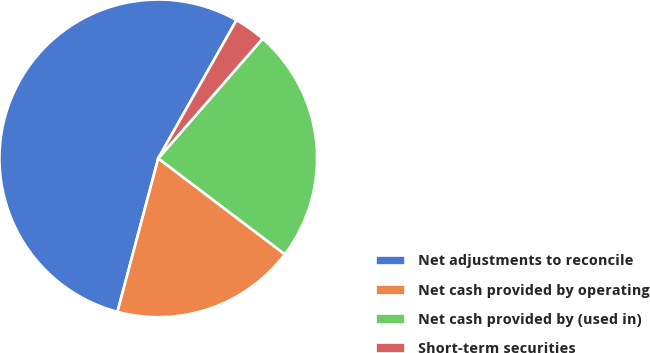Convert chart to OTSL. <chart><loc_0><loc_0><loc_500><loc_500><pie_chart><fcel>Net adjustments to reconcile<fcel>Net cash provided by operating<fcel>Net cash provided by (used in)<fcel>Short-term securities<nl><fcel>54.06%<fcel>18.82%<fcel>23.91%<fcel>3.21%<nl></chart> 